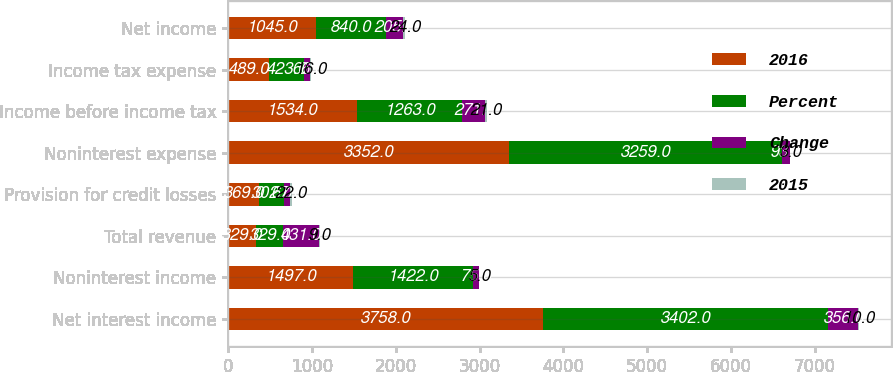Convert chart. <chart><loc_0><loc_0><loc_500><loc_500><stacked_bar_chart><ecel><fcel>Net interest income<fcel>Noninterest income<fcel>Total revenue<fcel>Provision for credit losses<fcel>Noninterest expense<fcel>Income before income tax<fcel>Income tax expense<fcel>Net income<nl><fcel>2016<fcel>3758<fcel>1497<fcel>329<fcel>369<fcel>3352<fcel>1534<fcel>489<fcel>1045<nl><fcel>Percent<fcel>3402<fcel>1422<fcel>329<fcel>302<fcel>3259<fcel>1263<fcel>423<fcel>840<nl><fcel>Change<fcel>356<fcel>75<fcel>431<fcel>67<fcel>93<fcel>271<fcel>66<fcel>205<nl><fcel>2015<fcel>10<fcel>5<fcel>9<fcel>22<fcel>3<fcel>21<fcel>16<fcel>24<nl></chart> 